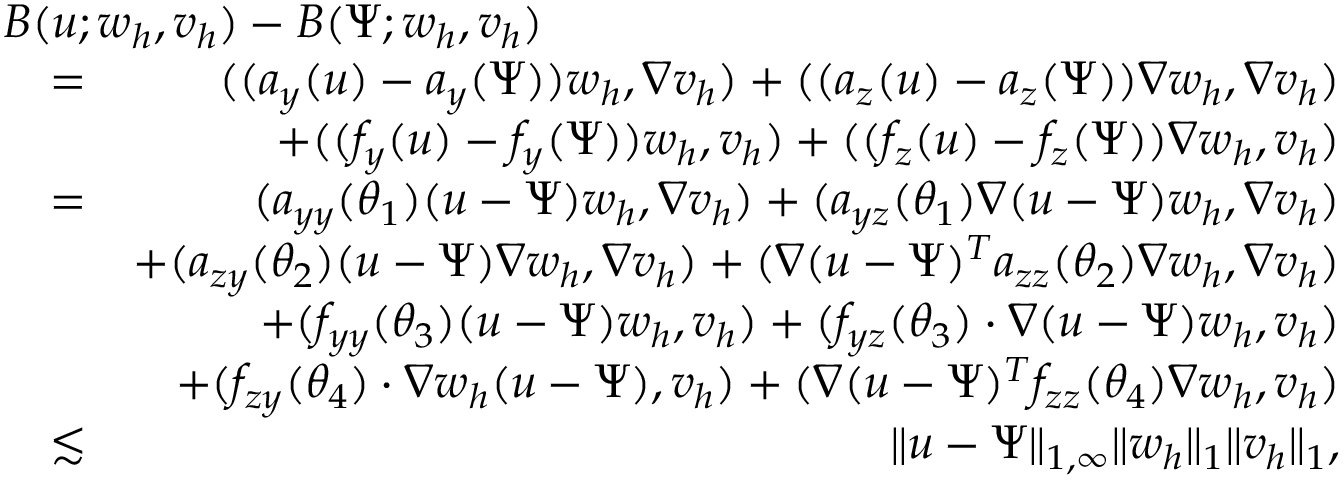Convert formula to latex. <formula><loc_0><loc_0><loc_500><loc_500>\begin{array} { r l r } { { B ( u ; w _ { h } , v _ { h } ) - B ( \Psi ; w _ { h } , v _ { h } ) } } \\ & { = } & { ( ( a _ { y } ( u ) - a _ { y } ( \Psi ) ) w _ { h } , \nabla v _ { h } ) + ( ( a _ { z } ( u ) - a _ { z } ( \Psi ) ) \nabla w _ { h } , \nabla v _ { h } ) } \\ & { + ( ( f _ { y } ( u ) - f _ { y } ( \Psi ) ) w _ { h } , v _ { h } ) + ( ( f _ { z } ( u ) - f _ { z } ( \Psi ) ) \nabla w _ { h } , v _ { h } ) } \\ & { = } & { ( a _ { y y } ( \theta _ { 1 } ) ( u - \Psi ) w _ { h } , \nabla v _ { h } ) + ( a _ { y z } ( \theta _ { 1 } ) \nabla ( u - \Psi ) w _ { h } , \nabla v _ { h } ) } \\ & { + ( a _ { z y } ( \theta _ { 2 } ) ( u - \Psi ) \nabla w _ { h } , \nabla v _ { h } ) + ( \nabla ( u - \Psi ) ^ { T } a _ { z z } ( \theta _ { 2 } ) \nabla w _ { h } , \nabla v _ { h } ) } \\ & { + ( f _ { y y } ( \theta _ { 3 } ) ( u - \Psi ) w _ { h } , v _ { h } ) + ( f _ { y z } ( \theta _ { 3 } ) \cdot \nabla ( u - \Psi ) w _ { h } , v _ { h } ) } \\ & { + ( f _ { z y } ( \theta _ { 4 } ) \cdot \nabla w _ { h } ( u - \Psi ) , v _ { h } ) + ( \nabla ( u - \Psi ) ^ { T } f _ { z z } ( \theta _ { 4 } ) \nabla w _ { h } , v _ { h } ) } \\ & { \lesssim } & { \| u - \Psi \| _ { 1 , \infty } \| w _ { h } \| _ { 1 } \| v _ { h } \| _ { 1 } , } \end{array}</formula> 